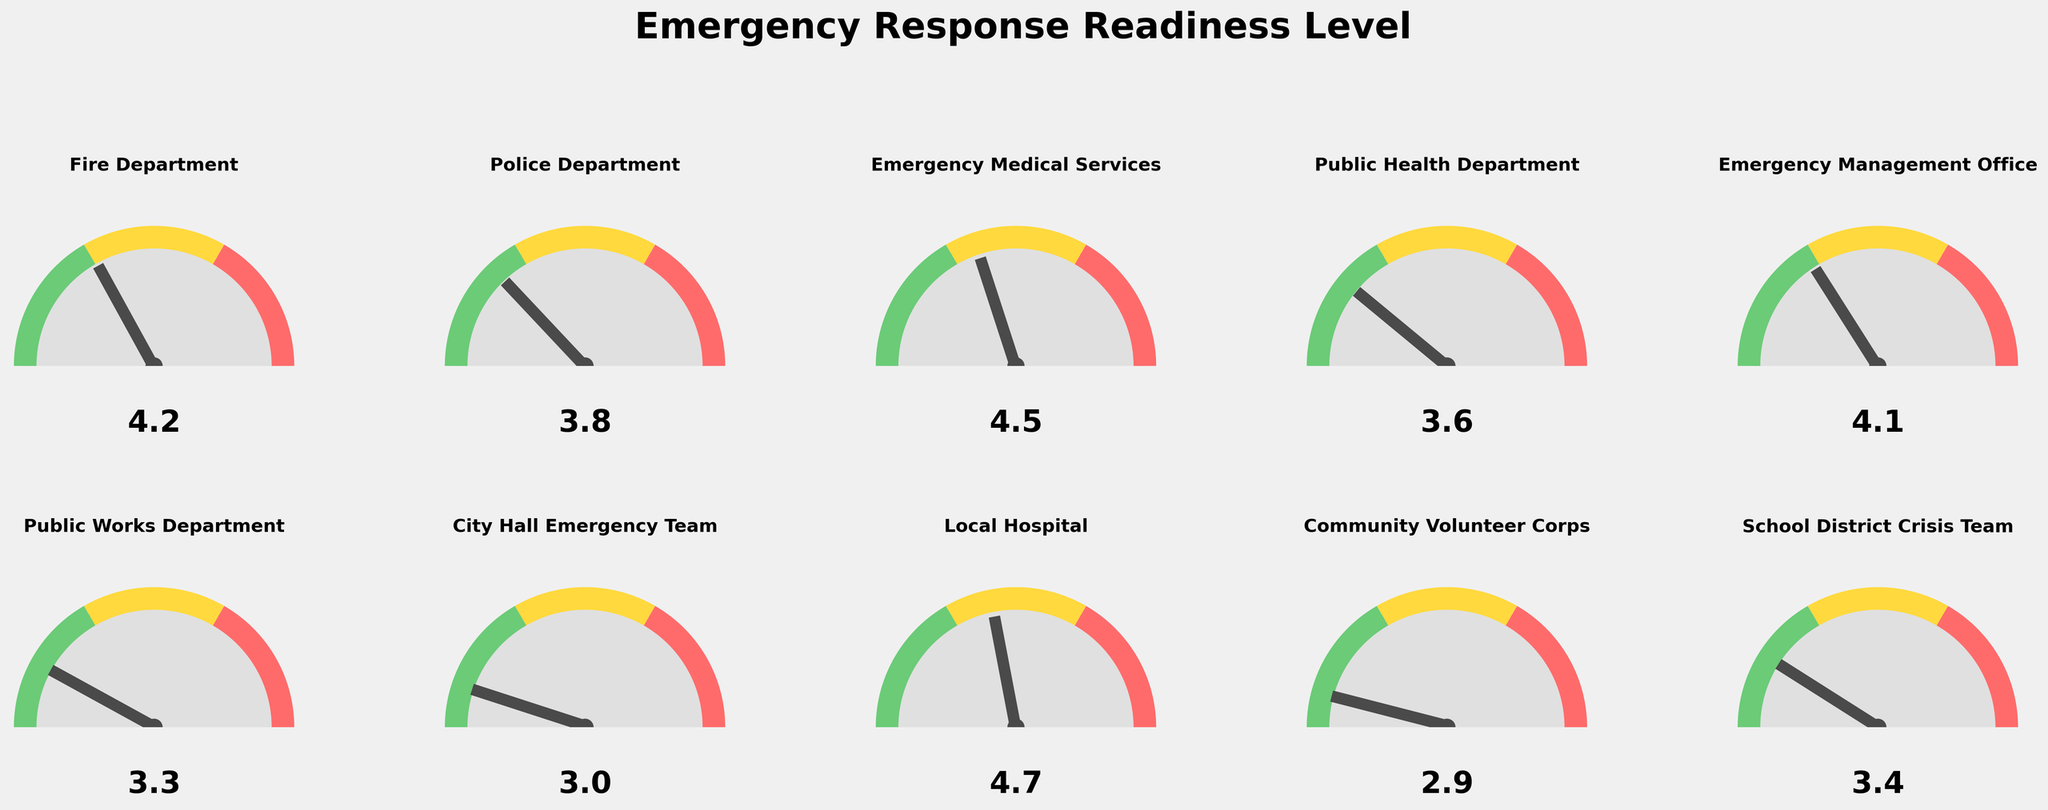What is the readiness level of the Fire Department? The Fire Department's readiness level is indicated on the plot as one of the gauges. According to the figure, the needle points to 4.2.
Answer: 4.2 Which entity has the highest emergency response readiness level? The entity with the highest readiness level is the one with the highest value next to its gauge needle. The Local Hospital has the highest value at 4.7.
Answer: Local Hospital What is the average readiness level of all the entities? To find the average readiness level, sum all scores and divide by the number of entities. The sum is (4.2 + 3.8 + 4.5 + 3.6 + 4.1 + 3.3 + 3.0 + 4.7 + 2.9 + 3.4) = 37.5. There are 10 entities, so the average is 37.5 / 10 = 3.75.
Answer: 3.75 Which departments have a readiness level above 4.0? By inspecting the gauges, the entities with readiness levels above 4.0 are the Fire Department (4.2), Emergency Medical Services (4.5), Emergency Management Office (4.1), and Local Hospital (4.7).
Answer: Fire Department, Emergency Medical Services, Emergency Management Office, Local Hospital What is the range of the readiness levels among the entities? The range is the difference between the highest and lowest values. The highest value is 4.7 (Local Hospital), and the lowest value is 2.9 (Community Volunteer Corps). The range is 4.7 - 2.9 = 1.8.
Answer: 1.8 Which department has the closest readiness level to 3.0? By analyzing the gauges, the department closest to 3.0 is the City Hall Emergency Team with a readiness level of exactly 3.0.
Answer: City Hall Emergency Team How many entities have a readiness level below the average? First, find the average readiness level, which is 3.75. Count the entities with scores below 3.75: Police Department (3.8), Public Health Department (3.6), Public Works Department (3.3), City Hall Emergency Team (3.0), Community Volunteer Corps (2.9), School District Crisis Team (3.4). Six entities are below the average.
Answer: 6 Which two departments have the most differing levels of readiness? The maximum difference in levels is between the Local Hospital (4.7) and the Community Volunteer Corps (2.9), a difference of 1.8.
Answer: Local Hospital and Community Volunteer Corps 